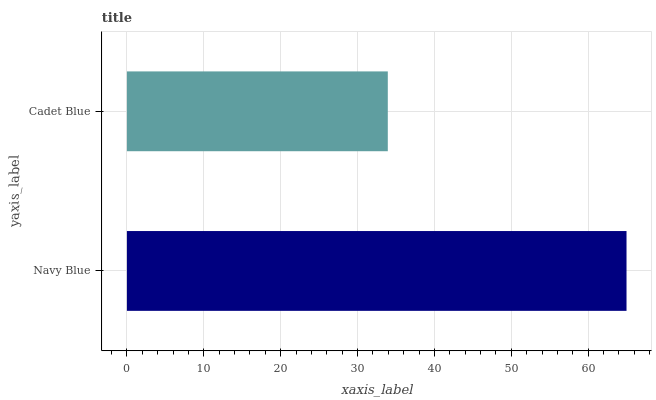Is Cadet Blue the minimum?
Answer yes or no. Yes. Is Navy Blue the maximum?
Answer yes or no. Yes. Is Cadet Blue the maximum?
Answer yes or no. No. Is Navy Blue greater than Cadet Blue?
Answer yes or no. Yes. Is Cadet Blue less than Navy Blue?
Answer yes or no. Yes. Is Cadet Blue greater than Navy Blue?
Answer yes or no. No. Is Navy Blue less than Cadet Blue?
Answer yes or no. No. Is Navy Blue the high median?
Answer yes or no. Yes. Is Cadet Blue the low median?
Answer yes or no. Yes. Is Cadet Blue the high median?
Answer yes or no. No. Is Navy Blue the low median?
Answer yes or no. No. 